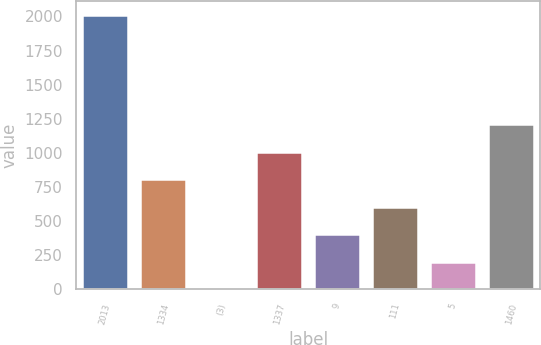Convert chart. <chart><loc_0><loc_0><loc_500><loc_500><bar_chart><fcel>2013<fcel>1334<fcel>(3)<fcel>1337<fcel>9<fcel>111<fcel>5<fcel>1460<nl><fcel>2013<fcel>805.22<fcel>0.02<fcel>1006.52<fcel>402.62<fcel>603.92<fcel>201.32<fcel>1207.82<nl></chart> 